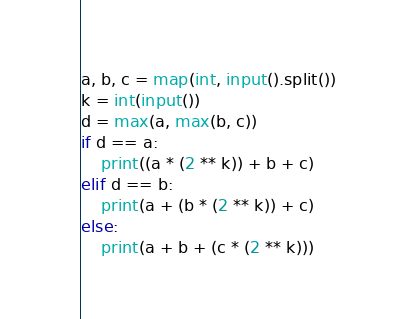Convert code to text. <code><loc_0><loc_0><loc_500><loc_500><_Python_>a, b, c = map(int, input().split())
k = int(input())
d = max(a, max(b, c))
if d == a:
    print((a * (2 ** k)) + b + c)
elif d == b:
    print(a + (b * (2 ** k)) + c)
else:
    print(a + b + (c * (2 ** k)))</code> 